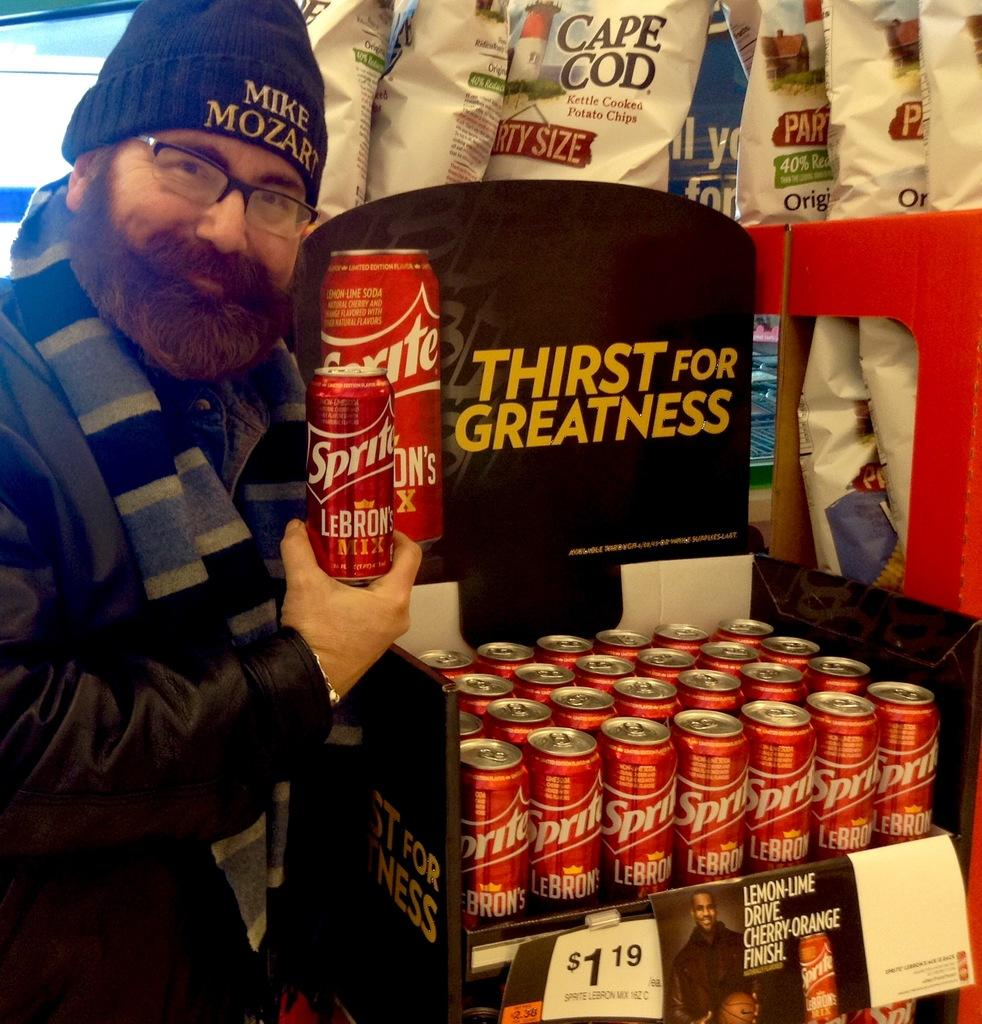<image>
Describe the image concisely. Multiple bottles of Sprite  arranged in a shelf near some potato chips. 